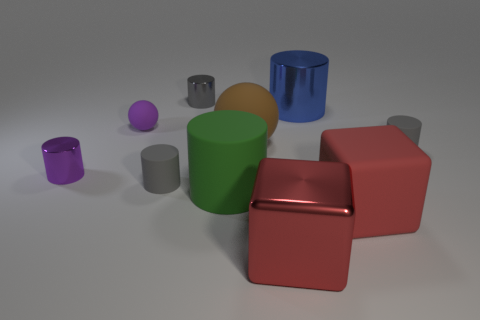What is the green thing made of?
Keep it short and to the point. Rubber. There is a object that is the same color as the tiny ball; what size is it?
Make the answer very short. Small. What number of other things are the same size as the green thing?
Your response must be concise. 4. How many big shiny cubes are there?
Your answer should be compact. 1. Does the red metallic cube have the same size as the purple sphere?
Provide a succinct answer. No. How many other things are the same shape as the tiny purple metal object?
Provide a succinct answer. 5. What material is the tiny thing that is behind the big metal object behind the brown ball made of?
Your answer should be very brief. Metal. There is a red shiny thing; are there any rubber objects right of it?
Your answer should be compact. Yes. There is a blue metallic object; does it have the same size as the matte ball on the left side of the gray metal cylinder?
Give a very brief answer. No. There is a purple thing that is the same shape as the large brown object; what is its size?
Keep it short and to the point. Small. 